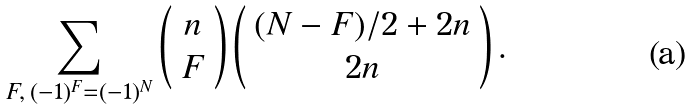<formula> <loc_0><loc_0><loc_500><loc_500>\sum _ { F , \, ( - 1 ) ^ { F } = ( - 1 ) ^ { N } } \left ( \begin{array} { c } n \\ F \end{array} \right ) \left ( \begin{array} { c } ( N - F ) / 2 + 2 n \\ 2 n \end{array} \right ) .</formula> 